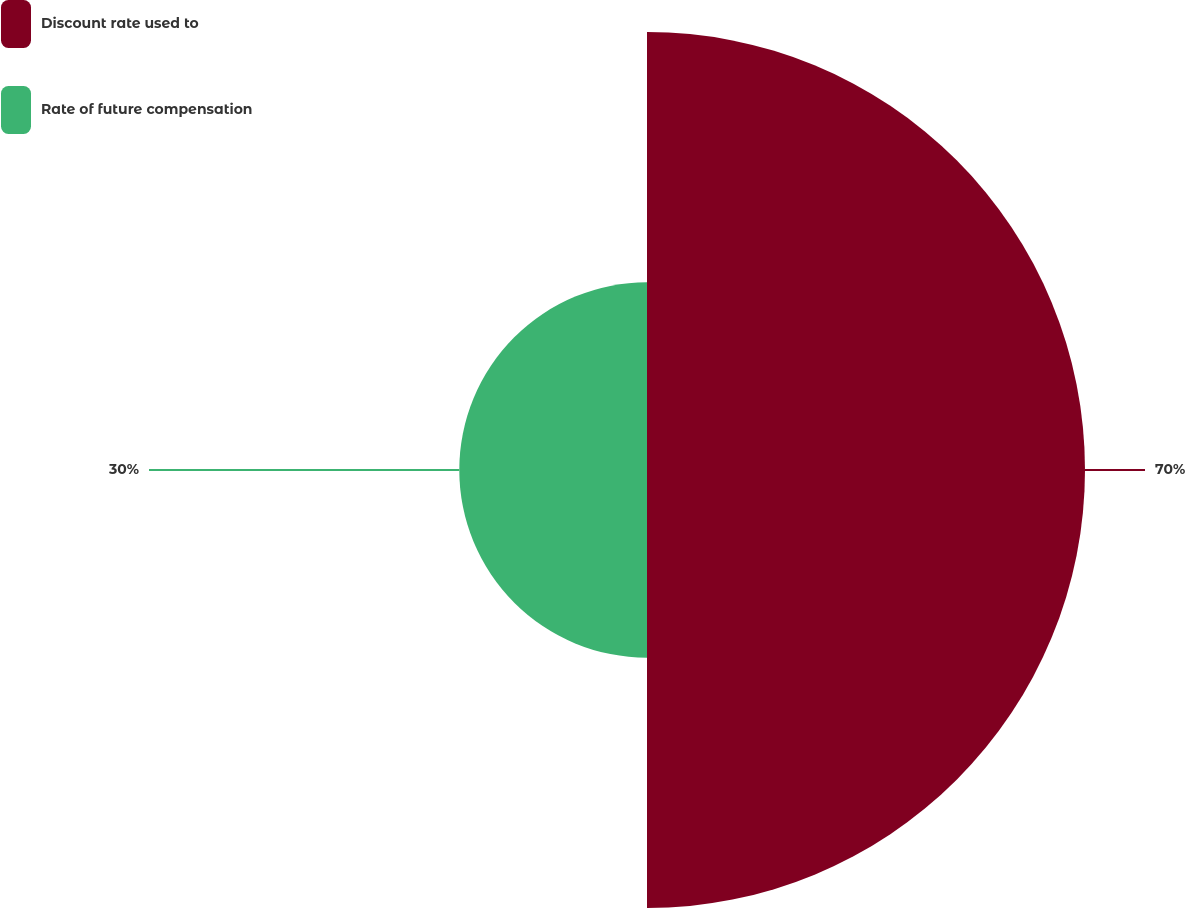<chart> <loc_0><loc_0><loc_500><loc_500><pie_chart><fcel>Discount rate used to<fcel>Rate of future compensation<nl><fcel>70.0%<fcel>30.0%<nl></chart> 